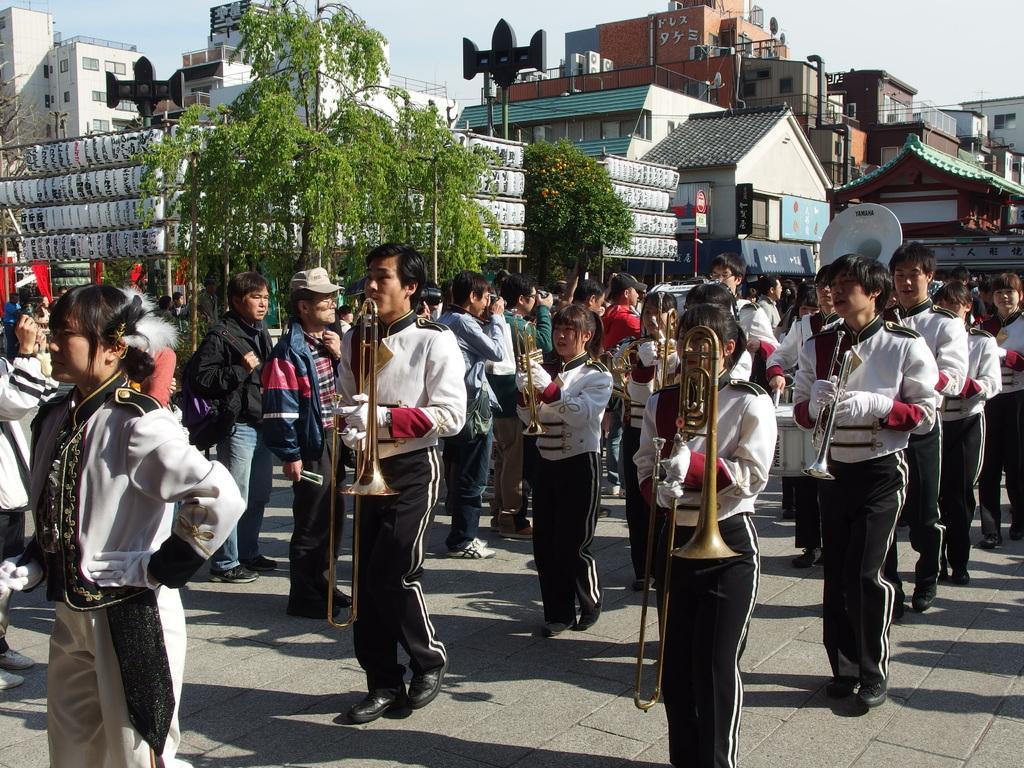Describe this image in one or two sentences. In this image I can see there are few persons wearing a white color t-shirt and black color pant ,holding the musical instruments standing on the floor and some persons taking the picture the picture and I can see the building and trees 